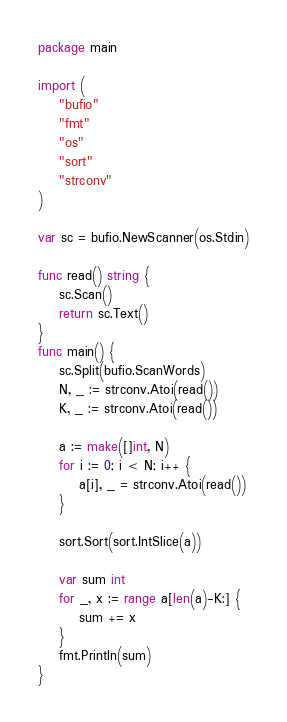<code> <loc_0><loc_0><loc_500><loc_500><_Go_>package main

import (
	"bufio"
	"fmt"
	"os"
	"sort"
	"strconv"
)

var sc = bufio.NewScanner(os.Stdin)

func read() string {
	sc.Scan()
	return sc.Text()
}
func main() {
	sc.Split(bufio.ScanWords)
	N, _ := strconv.Atoi(read())
	K, _ := strconv.Atoi(read())

	a := make([]int, N)
	for i := 0; i < N; i++ {
		a[i], _ = strconv.Atoi(read())
	}

	sort.Sort(sort.IntSlice(a))

	var sum int
	for _, x := range a[len(a)-K:] {
		sum += x
	}
	fmt.Println(sum)
}
</code> 